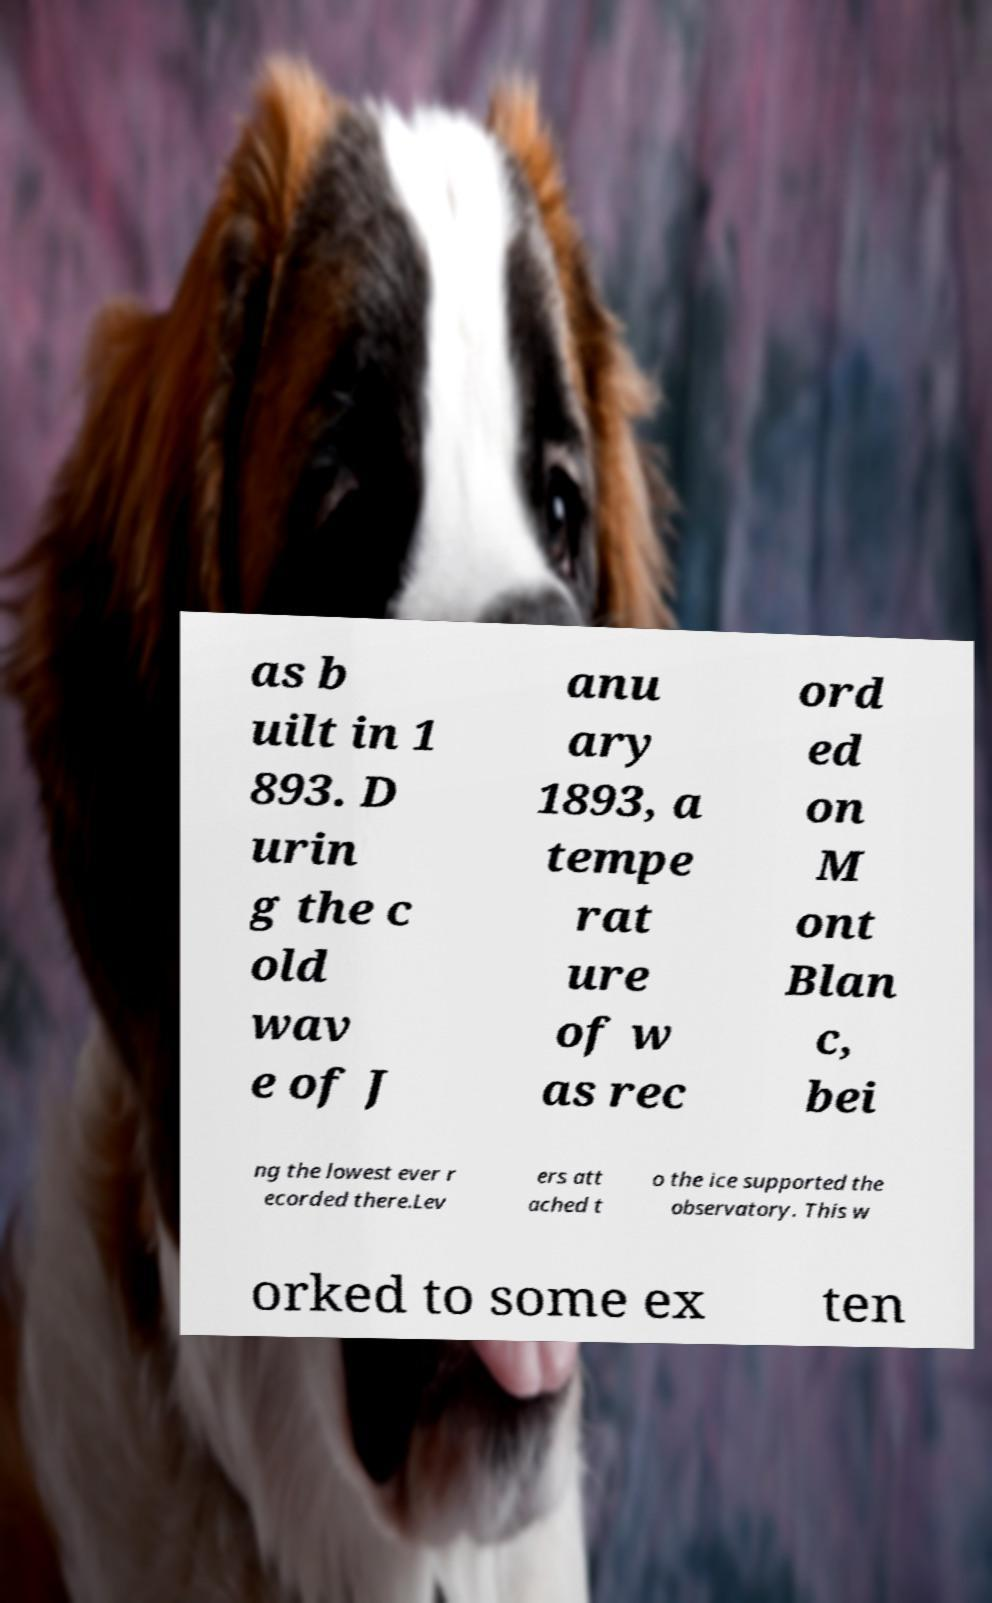Can you accurately transcribe the text from the provided image for me? as b uilt in 1 893. D urin g the c old wav e of J anu ary 1893, a tempe rat ure of w as rec ord ed on M ont Blan c, bei ng the lowest ever r ecorded there.Lev ers att ached t o the ice supported the observatory. This w orked to some ex ten 